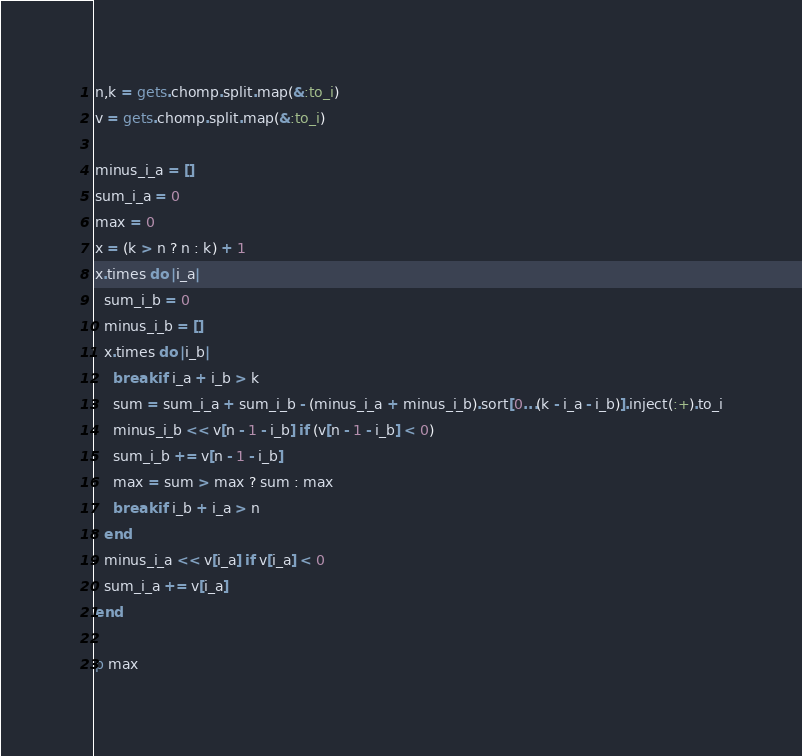Convert code to text. <code><loc_0><loc_0><loc_500><loc_500><_Ruby_>n,k = gets.chomp.split.map(&:to_i)
v = gets.chomp.split.map(&:to_i)

minus_i_a = []
sum_i_a = 0
max = 0
x = (k > n ? n : k) + 1
x.times do |i_a|
  sum_i_b = 0
  minus_i_b = []
  x.times do |i_b|
    break if i_a + i_b > k
    sum = sum_i_a + sum_i_b - (minus_i_a + minus_i_b).sort[0...(k - i_a - i_b)].inject(:+).to_i
    minus_i_b << v[n - 1 - i_b] if (v[n - 1 - i_b] < 0)
    sum_i_b += v[n - 1 - i_b]
    max = sum > max ? sum : max
    break if i_b + i_a > n
  end
  minus_i_a << v[i_a] if v[i_a] < 0
  sum_i_a += v[i_a]
end

p max</code> 